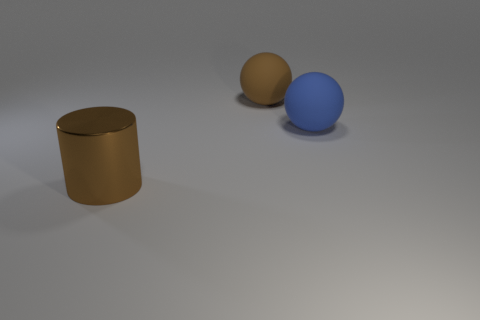Add 3 blue rubber objects. How many objects exist? 6 Subtract all blue matte things. Subtract all large brown balls. How many objects are left? 1 Add 3 big brown rubber objects. How many big brown rubber objects are left? 4 Add 2 tiny gray shiny blocks. How many tiny gray shiny blocks exist? 2 Subtract 0 yellow cylinders. How many objects are left? 3 Subtract all balls. How many objects are left? 1 